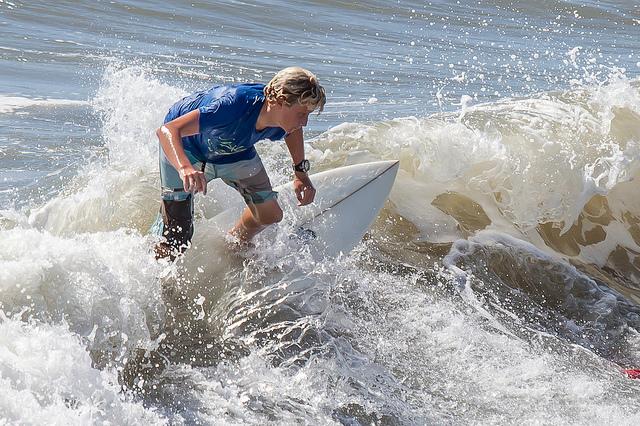Is the man wearing short or long sleeves?
Short answer required. Short. What is the man doing?
Quick response, please. Surfing. Does this person look wet?
Answer briefly. Yes. 